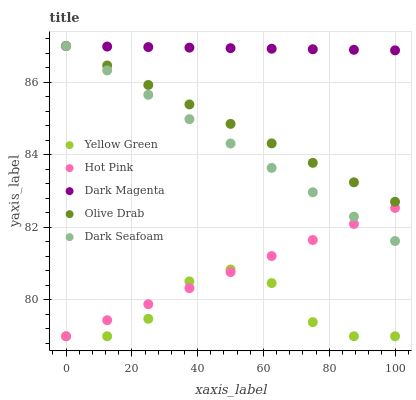Does Yellow Green have the minimum area under the curve?
Answer yes or no. Yes. Does Dark Magenta have the maximum area under the curve?
Answer yes or no. Yes. Does Hot Pink have the minimum area under the curve?
Answer yes or no. No. Does Hot Pink have the maximum area under the curve?
Answer yes or no. No. Is Dark Seafoam the smoothest?
Answer yes or no. Yes. Is Yellow Green the roughest?
Answer yes or no. Yes. Is Yellow Green the smoothest?
Answer yes or no. No. Is Hot Pink the roughest?
Answer yes or no. No. Does Hot Pink have the lowest value?
Answer yes or no. Yes. Does Olive Drab have the lowest value?
Answer yes or no. No. Does Dark Magenta have the highest value?
Answer yes or no. Yes. Does Hot Pink have the highest value?
Answer yes or no. No. Is Hot Pink less than Dark Magenta?
Answer yes or no. Yes. Is Dark Magenta greater than Hot Pink?
Answer yes or no. Yes. Does Dark Seafoam intersect Olive Drab?
Answer yes or no. Yes. Is Dark Seafoam less than Olive Drab?
Answer yes or no. No. Is Dark Seafoam greater than Olive Drab?
Answer yes or no. No. Does Hot Pink intersect Dark Magenta?
Answer yes or no. No. 